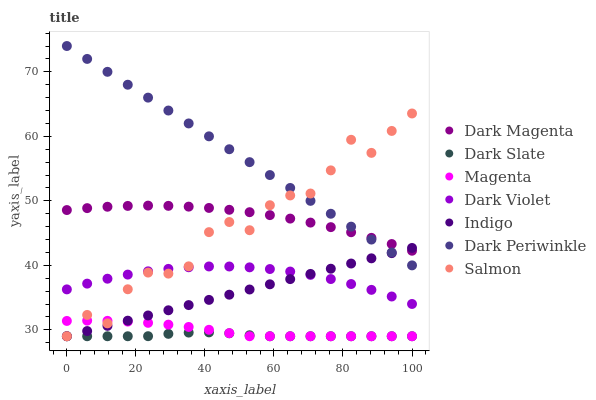Does Dark Slate have the minimum area under the curve?
Answer yes or no. Yes. Does Dark Periwinkle have the maximum area under the curve?
Answer yes or no. Yes. Does Dark Magenta have the minimum area under the curve?
Answer yes or no. No. Does Dark Magenta have the maximum area under the curve?
Answer yes or no. No. Is Indigo the smoothest?
Answer yes or no. Yes. Is Salmon the roughest?
Answer yes or no. Yes. Is Dark Magenta the smoothest?
Answer yes or no. No. Is Dark Magenta the roughest?
Answer yes or no. No. Does Indigo have the lowest value?
Answer yes or no. Yes. Does Dark Magenta have the lowest value?
Answer yes or no. No. Does Dark Periwinkle have the highest value?
Answer yes or no. Yes. Does Dark Magenta have the highest value?
Answer yes or no. No. Is Dark Slate less than Dark Periwinkle?
Answer yes or no. Yes. Is Dark Periwinkle greater than Dark Slate?
Answer yes or no. Yes. Does Dark Slate intersect Magenta?
Answer yes or no. Yes. Is Dark Slate less than Magenta?
Answer yes or no. No. Is Dark Slate greater than Magenta?
Answer yes or no. No. Does Dark Slate intersect Dark Periwinkle?
Answer yes or no. No. 